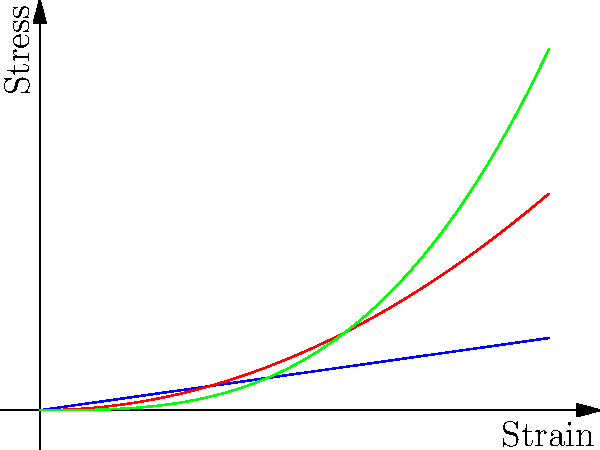In a Total Quality Management (TQM) approach to material selection for a new product, you're analyzing stress-strain curves from tensile tests. Based on the graph, which material would you recommend for an application requiring high stiffness but limited ductility? To answer this question, we need to analyze the stress-strain curves for each material:

1. Material A (blue line): Shows a linear relationship between stress and strain, indicating elastic behavior. This is characteristic of a stiff material with limited ductility.

2. Material B (red line): Exhibits a parabolic curve, suggesting some non-linear elasticity or plasticity. This material is less stiff than A and likely more ductile.

3. Material C (green line): Displays a cubic relationship, indicating the most non-linear behavior and potentially the highest ductility.

Stiffness is represented by the slope of the stress-strain curve in the elastic region. A steeper slope indicates higher stiffness. Material A has the steepest initial slope, making it the stiffest.

Ductility is related to the ability of a material to deform plastically without fracture. Materials with limited ductility typically have shorter stress-strain curves before failure. Material A shows the most limited curve, suggesting the least ductility.

In a TQM context, selecting Material A would align with the requirement for high stiffness and limited ductility. This choice would contribute to product quality by ensuring the component maintains its shape under load while avoiding excessive deformation.
Answer: Material A 